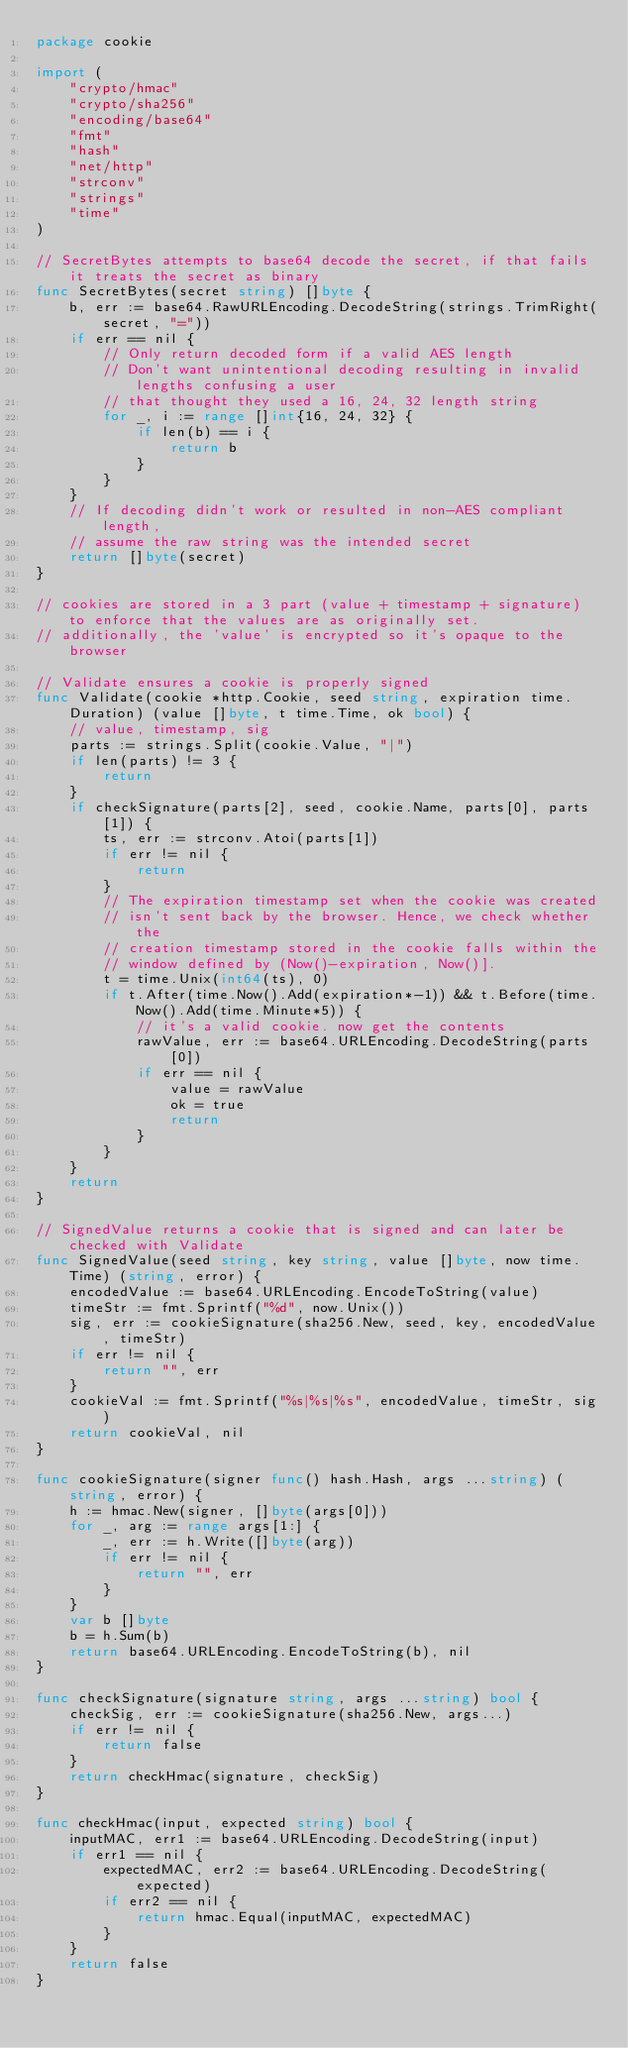<code> <loc_0><loc_0><loc_500><loc_500><_Go_>package cookie

import (
	"crypto/hmac"
	"crypto/sha256"
	"encoding/base64"
	"fmt"
	"hash"
	"net/http"
	"strconv"
	"strings"
	"time"
)

// SecretBytes attempts to base64 decode the secret, if that fails it treats the secret as binary
func SecretBytes(secret string) []byte {
	b, err := base64.RawURLEncoding.DecodeString(strings.TrimRight(secret, "="))
	if err == nil {
		// Only return decoded form if a valid AES length
		// Don't want unintentional decoding resulting in invalid lengths confusing a user
		// that thought they used a 16, 24, 32 length string
		for _, i := range []int{16, 24, 32} {
			if len(b) == i {
				return b
			}
		}
	}
	// If decoding didn't work or resulted in non-AES compliant length,
	// assume the raw string was the intended secret
	return []byte(secret)
}

// cookies are stored in a 3 part (value + timestamp + signature) to enforce that the values are as originally set.
// additionally, the 'value' is encrypted so it's opaque to the browser

// Validate ensures a cookie is properly signed
func Validate(cookie *http.Cookie, seed string, expiration time.Duration) (value []byte, t time.Time, ok bool) {
	// value, timestamp, sig
	parts := strings.Split(cookie.Value, "|")
	if len(parts) != 3 {
		return
	}
	if checkSignature(parts[2], seed, cookie.Name, parts[0], parts[1]) {
		ts, err := strconv.Atoi(parts[1])
		if err != nil {
			return
		}
		// The expiration timestamp set when the cookie was created
		// isn't sent back by the browser. Hence, we check whether the
		// creation timestamp stored in the cookie falls within the
		// window defined by (Now()-expiration, Now()].
		t = time.Unix(int64(ts), 0)
		if t.After(time.Now().Add(expiration*-1)) && t.Before(time.Now().Add(time.Minute*5)) {
			// it's a valid cookie. now get the contents
			rawValue, err := base64.URLEncoding.DecodeString(parts[0])
			if err == nil {
				value = rawValue
				ok = true
				return
			}
		}
	}
	return
}

// SignedValue returns a cookie that is signed and can later be checked with Validate
func SignedValue(seed string, key string, value []byte, now time.Time) (string, error) {
	encodedValue := base64.URLEncoding.EncodeToString(value)
	timeStr := fmt.Sprintf("%d", now.Unix())
	sig, err := cookieSignature(sha256.New, seed, key, encodedValue, timeStr)
	if err != nil {
		return "", err
	}
	cookieVal := fmt.Sprintf("%s|%s|%s", encodedValue, timeStr, sig)
	return cookieVal, nil
}

func cookieSignature(signer func() hash.Hash, args ...string) (string, error) {
	h := hmac.New(signer, []byte(args[0]))
	for _, arg := range args[1:] {
		_, err := h.Write([]byte(arg))
		if err != nil {
			return "", err
		}
	}
	var b []byte
	b = h.Sum(b)
	return base64.URLEncoding.EncodeToString(b), nil
}

func checkSignature(signature string, args ...string) bool {
	checkSig, err := cookieSignature(sha256.New, args...)
	if err != nil {
		return false
	}
	return checkHmac(signature, checkSig)
}

func checkHmac(input, expected string) bool {
	inputMAC, err1 := base64.URLEncoding.DecodeString(input)
	if err1 == nil {
		expectedMAC, err2 := base64.URLEncoding.DecodeString(expected)
		if err2 == nil {
			return hmac.Equal(inputMAC, expectedMAC)
		}
	}
	return false
}
</code> 